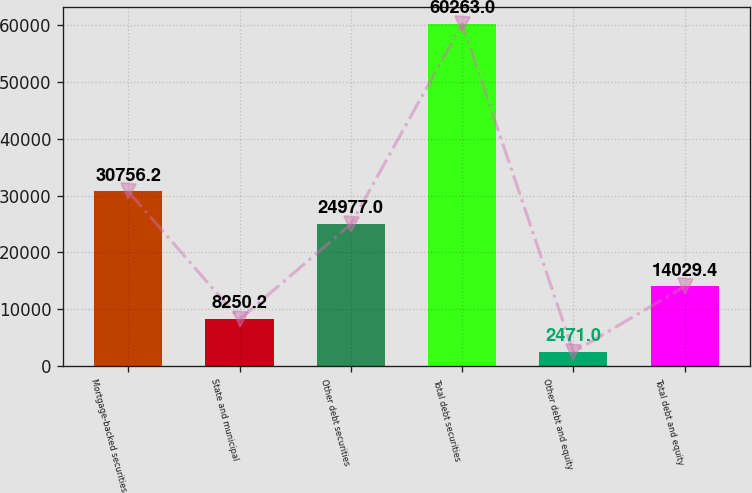Convert chart. <chart><loc_0><loc_0><loc_500><loc_500><bar_chart><fcel>Mortgage-backed securities<fcel>State and municipal<fcel>Other debt securities<fcel>Total debt securities<fcel>Other debt and equity<fcel>Total debt and equity<nl><fcel>30756.2<fcel>8250.2<fcel>24977<fcel>60263<fcel>2471<fcel>14029.4<nl></chart> 